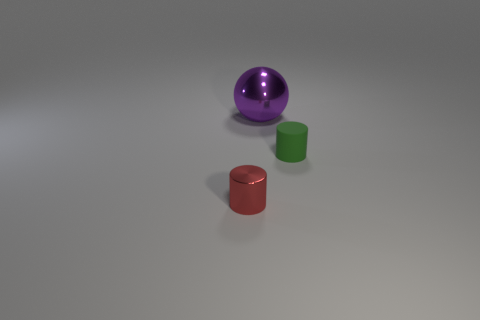What shape is the other thing that is the same size as the green thing?
Keep it short and to the point. Cylinder. Is there a green rubber thing that has the same shape as the tiny red object?
Provide a short and direct response. Yes. There is a metallic object behind the tiny cylinder on the right side of the tiny red cylinder; what is its shape?
Give a very brief answer. Sphere. The large purple object is what shape?
Give a very brief answer. Sphere. There is a cylinder to the right of the thing behind the cylinder on the right side of the small red thing; what is its material?
Ensure brevity in your answer.  Rubber. How many other objects are the same material as the ball?
Your answer should be compact. 1. There is a small cylinder behind the red shiny cylinder; what number of small green things are to the left of it?
Keep it short and to the point. 0. How many cylinders are small cyan things or shiny objects?
Offer a terse response. 1. There is a object that is in front of the large ball and to the left of the tiny matte cylinder; what is its color?
Offer a very short reply. Red. What is the color of the shiny object that is in front of the small object that is on the right side of the big sphere?
Your answer should be compact. Red. 